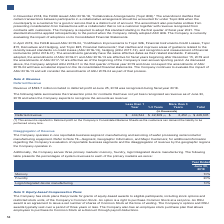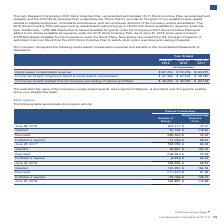According to Lam Research Corporation's financial document, What is the employee stock purchase plan? allows employees to purchase its Common Stock at a discount through payroll deductions. The document states: "any also has an employee stock purchase plan that allows employees to purchase its Common Stock at a discount through payroll deductions...." Also, How many shares were authorised for issuance under the 2015 Stock Incentive Plan? up to 18,000,000 shares. The document states: "ive Plan was approved by shareholders authorizing up to 18,000,000 shares available for issuance under the plan. Additionally, 1,232,068 shares that r..." Also, What is the total number of shares available for future issuance under the Stock Plans as of June 30, 2019? According to the financial document, 9,379,904 shares. The relevant text states: "Plan. As of June 30, 2019, there were a total of 9,379,904 shares available for future issuance under the Stock Plans. New shares are issued from the Company’s balan..." Also, can you calculate: What is the percentage change in the Equity-based compensation expense from 2018 to 2019? To answer this question, I need to perform calculations using the financial data. The calculation is: (187,234-172,216)/172,216, which equals 8.72 (percentage). This is based on the information: "Equity-based compensation expense $187,234 $172,216 $149,975 Equity-based compensation expense $187,234 $172,216 $149,975..." The key data points involved are: 172,216, 187,234. Also, can you calculate: What is the percentage change in the Income tax benefit recognized related to equity-based compensation from 2018 to 2019? To answer this question, I need to perform calculations using the financial data. The calculation is: (47,396-87,505)/87,505, which equals -45.84 (percentage). This is based on the information: "recognized related to equity-based compensation $ 47,396 $ 87,505 $ 38,381 d related to equity-based compensation $ 47,396 $ 87,505 $ 38,381..." The key data points involved are: 47,396, 87,505. Also, can you calculate: What is the percentage change in the Income tax benefit realized from the exercise and vesting of options and RSUs from 2018 to 2019? To answer this question, I need to perform calculations using the financial data. The calculation is: (49,242-90,297)/90,297, which equals -45.47 (percentage). This is based on the information: "om the exercise and vesting of options and RSUs $ 49,242 $ 90,297 $ 92,749 ercise and vesting of options and RSUs $ 49,242 $ 90,297 $ 92,749..." The key data points involved are: 49,242, 90,297. 